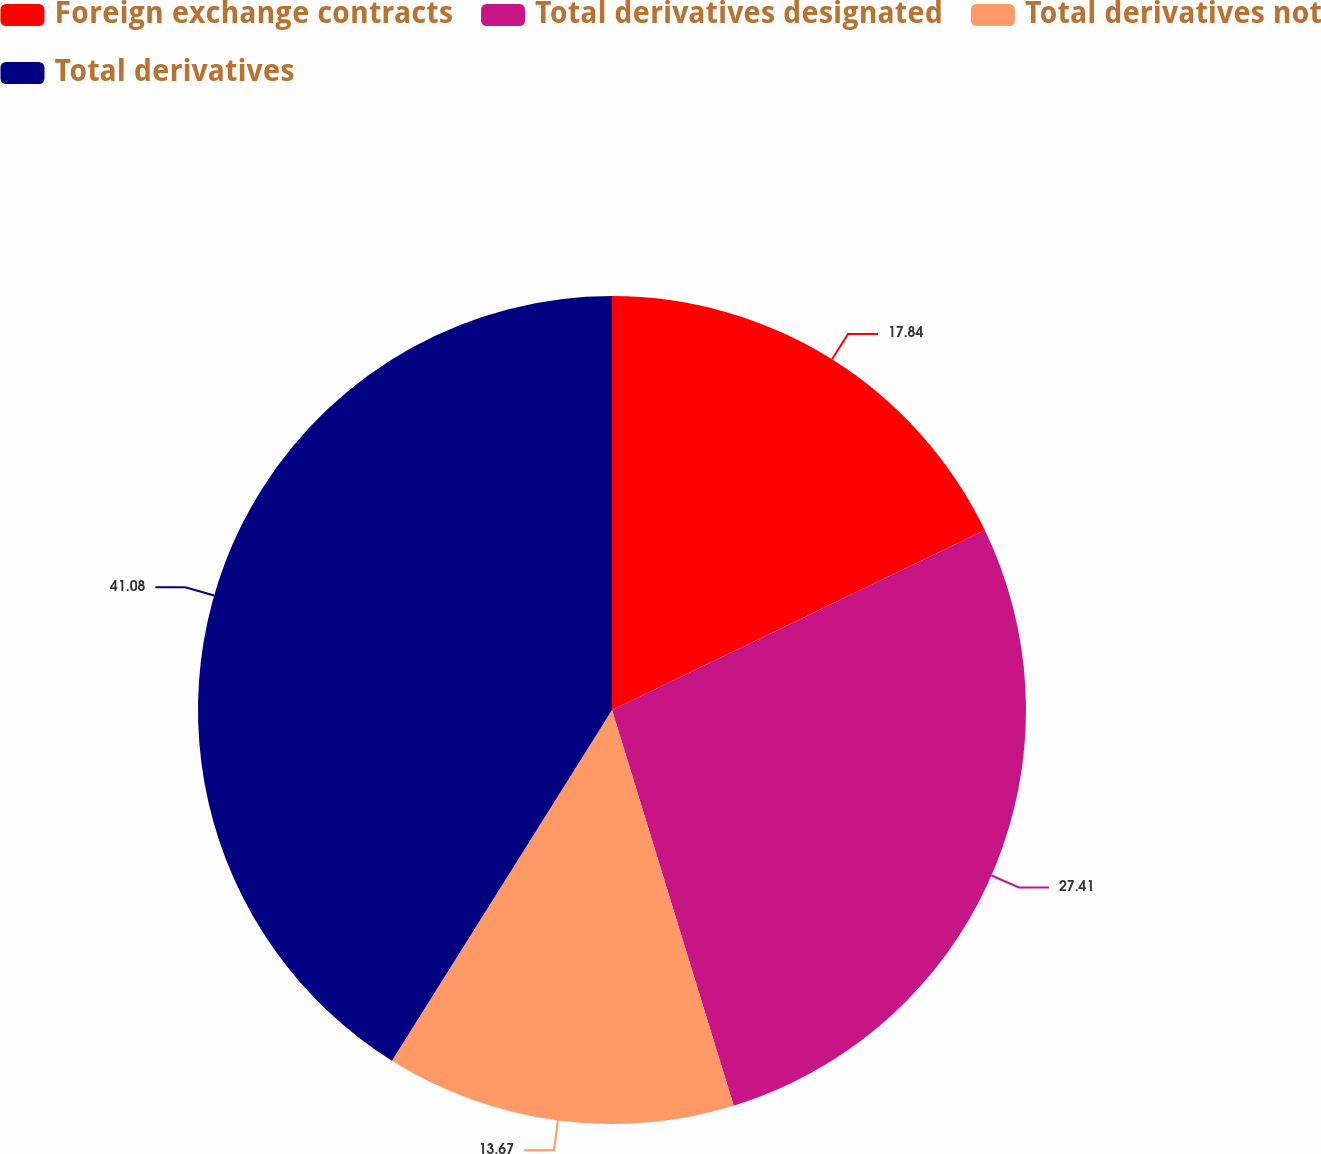<chart> <loc_0><loc_0><loc_500><loc_500><pie_chart><fcel>Foreign exchange contracts<fcel>Total derivatives designated<fcel>Total derivatives not<fcel>Total derivatives<nl><fcel>17.84%<fcel>27.41%<fcel>13.67%<fcel>41.08%<nl></chart> 